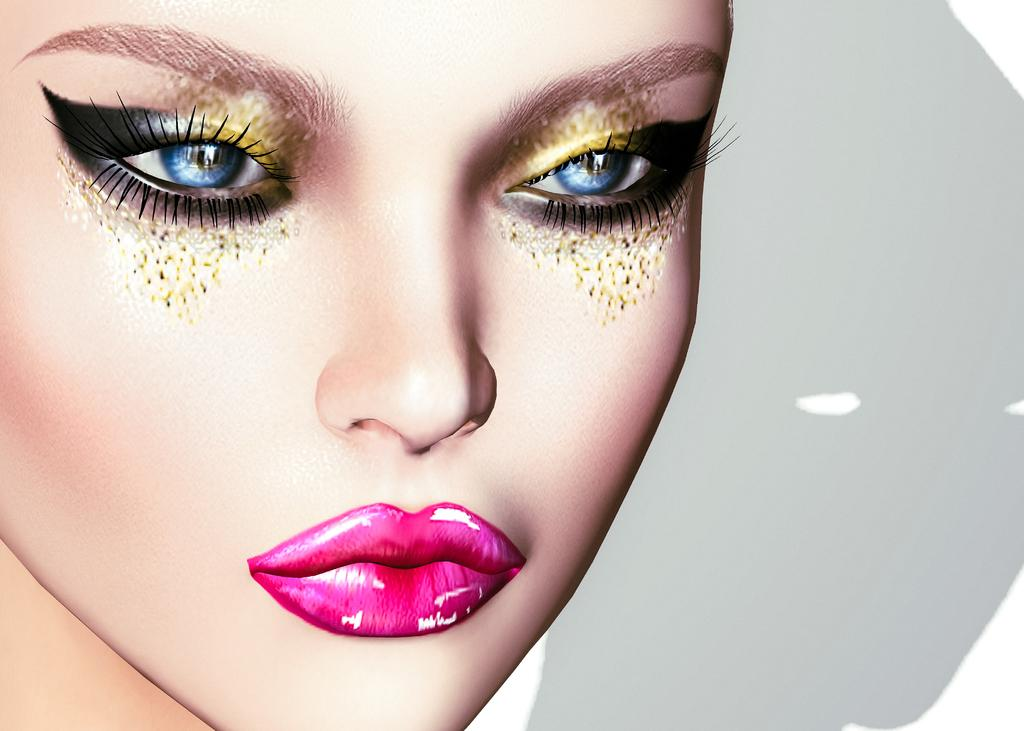What type of image is being described? The image is an animated picture. What can be seen in the animated picture? The face of a doll is visible in the image. Where is the spot on the doll's back in the image? There is no mention of a spot on the doll's back in the image, as the facts only mention the face of the doll being visible. 